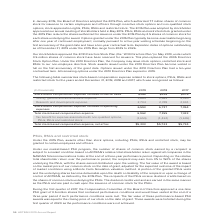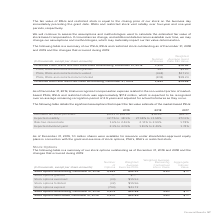According to Adtran's financial document, What was the number of shares of PSUs, RSUs and restricted stock granted  According to the financial document, 897 (in thousands). The relevant text states: "PSUs, RSUs and restricted stock granted 897 $9.63..." Also, What was the number of Unvested RSUs and restricted stock outstanding in 2018? According to the financial document, 1,570 (in thousands). The relevant text states: "d restricted stock outstanding, December 31, 2018 1,570 $18.52..." Also, What is the fair value of RSUs and restricted stock equal to? the closing price of our stock on the business day immediately preceding the grant date.. The document states: "air value of RSUs and restricted stock is equal to the closing price of our stock on the business day immediately preceding the grant date. RSUs and r..." Also, can you calculate: What was the change in Unvested RSUs and restricted stock outstanding between 2018 and 2019? Based on the calculation: 1,891-1,570, the result is 321 (in thousands). This is based on the information: "d restricted stock outstanding, December 31, 2018 1,570 $18.52 d restricted stock outstanding, December 31, 2019 1,891 $14.58..." The key data points involved are: 1,570, 1,891. Also, can you calculate: What was the difference between the weighted average grant date fair value of PSUs, RSUs and restricted stock that are granted as compared to those that are vested? Based on the calculation: $17.23-$9.63, the result is 7.6. This is based on the information: "PSUs, RSUs and restricted stock vested (368) $17.23 PSUs, RSUs and restricted stock granted 897 $9.63..." The key data points involved are: 17.23, 9.63. Also, can you calculate: What was the Weighted Average Grant Date Fair Value of unvested stocks in 2018 as a ratio of the fair value in 2019? Based on the calculation: $18.52/$14.58, the result is 1.27. This is based on the information: "icted stock outstanding, December 31, 2018 1,570 $18.52 icted stock outstanding, December 31, 2019 1,891 $14.58..." The key data points involved are: 14.58, 18.52. 